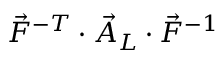<formula> <loc_0><loc_0><loc_500><loc_500>\vec { F } ^ { - T } \cdot \vec { A } _ { L } \cdot \vec { F } ^ { - 1 }</formula> 